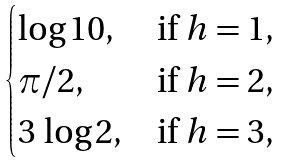Convert formula to latex. <formula><loc_0><loc_0><loc_500><loc_500>\begin{cases} \log 1 0 , & \text {if $h=1$,} \\ \pi / 2 , & \text {if $h=2$,} \\ 3 \, \log 2 , & \text {if $h=3$,} \end{cases}</formula> 